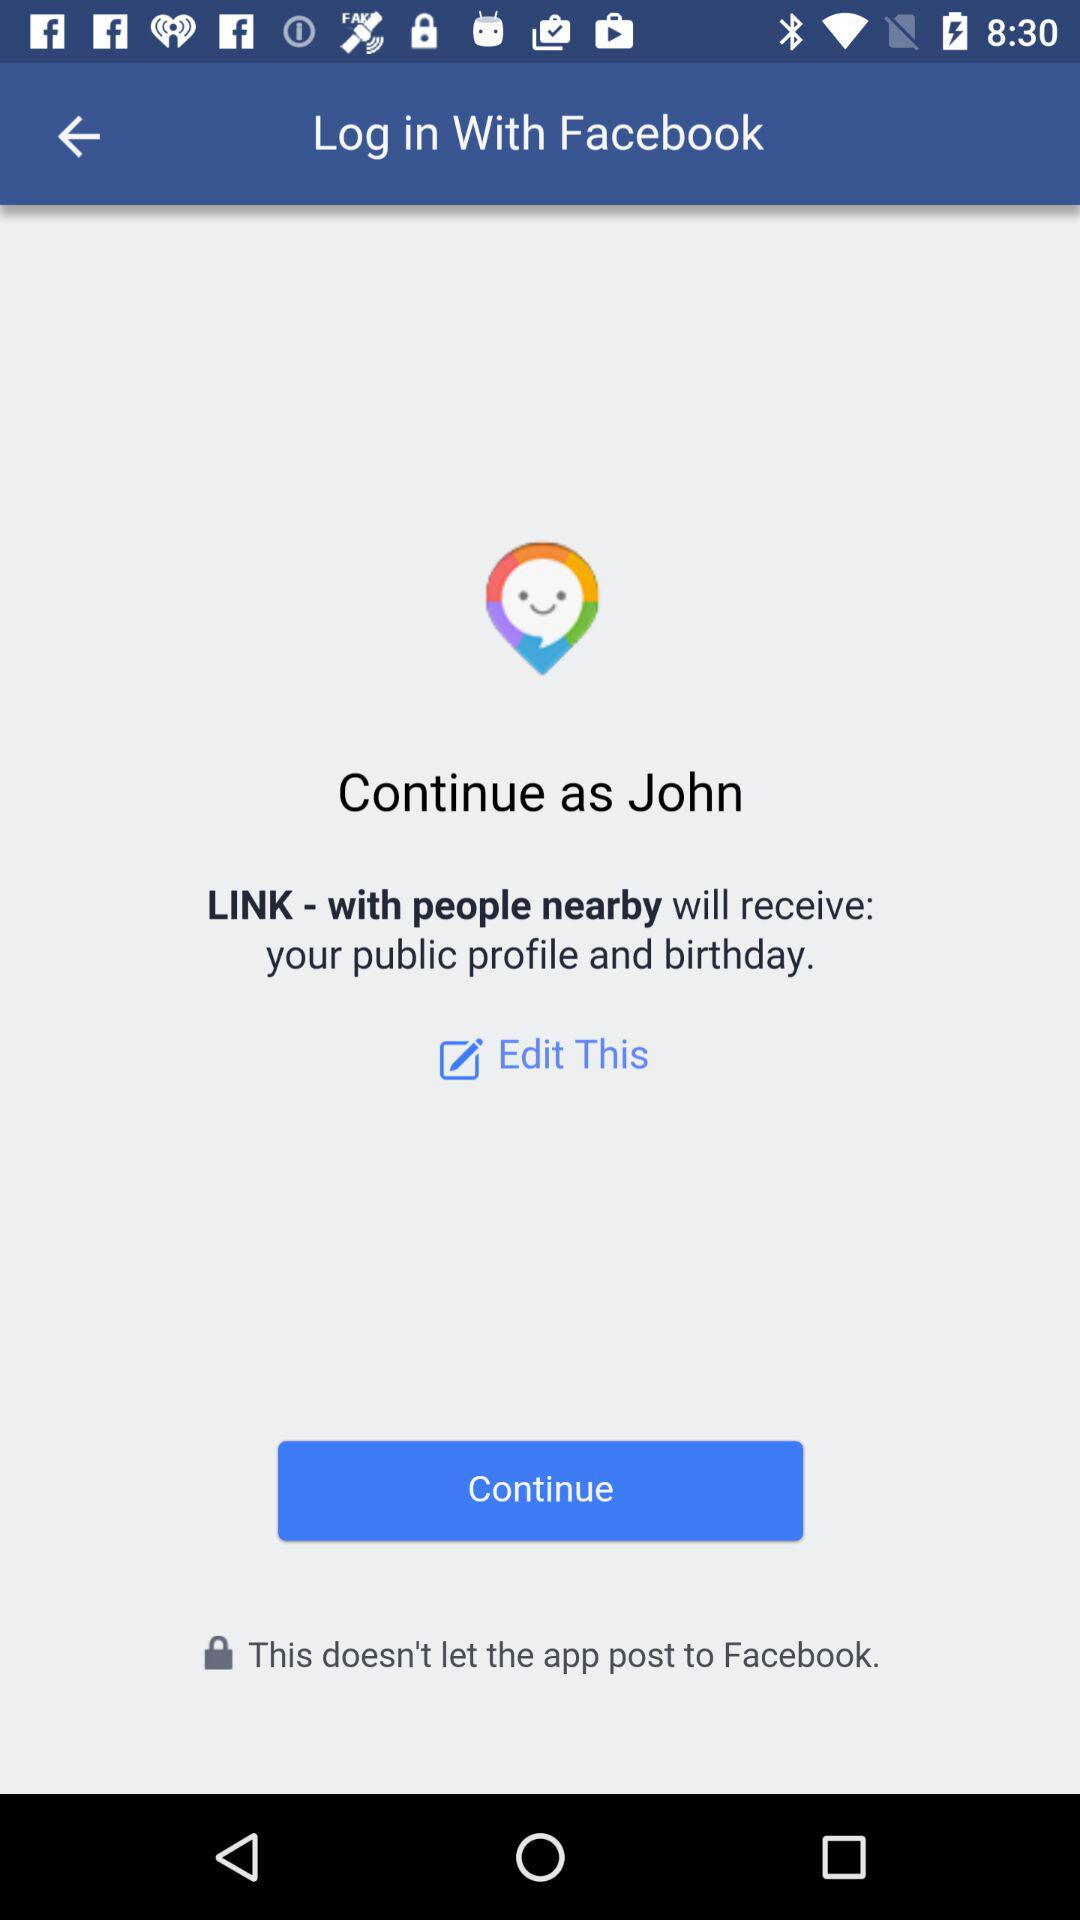Is this information edited?
When the provided information is insufficient, respond with <no answer>. <no answer> 